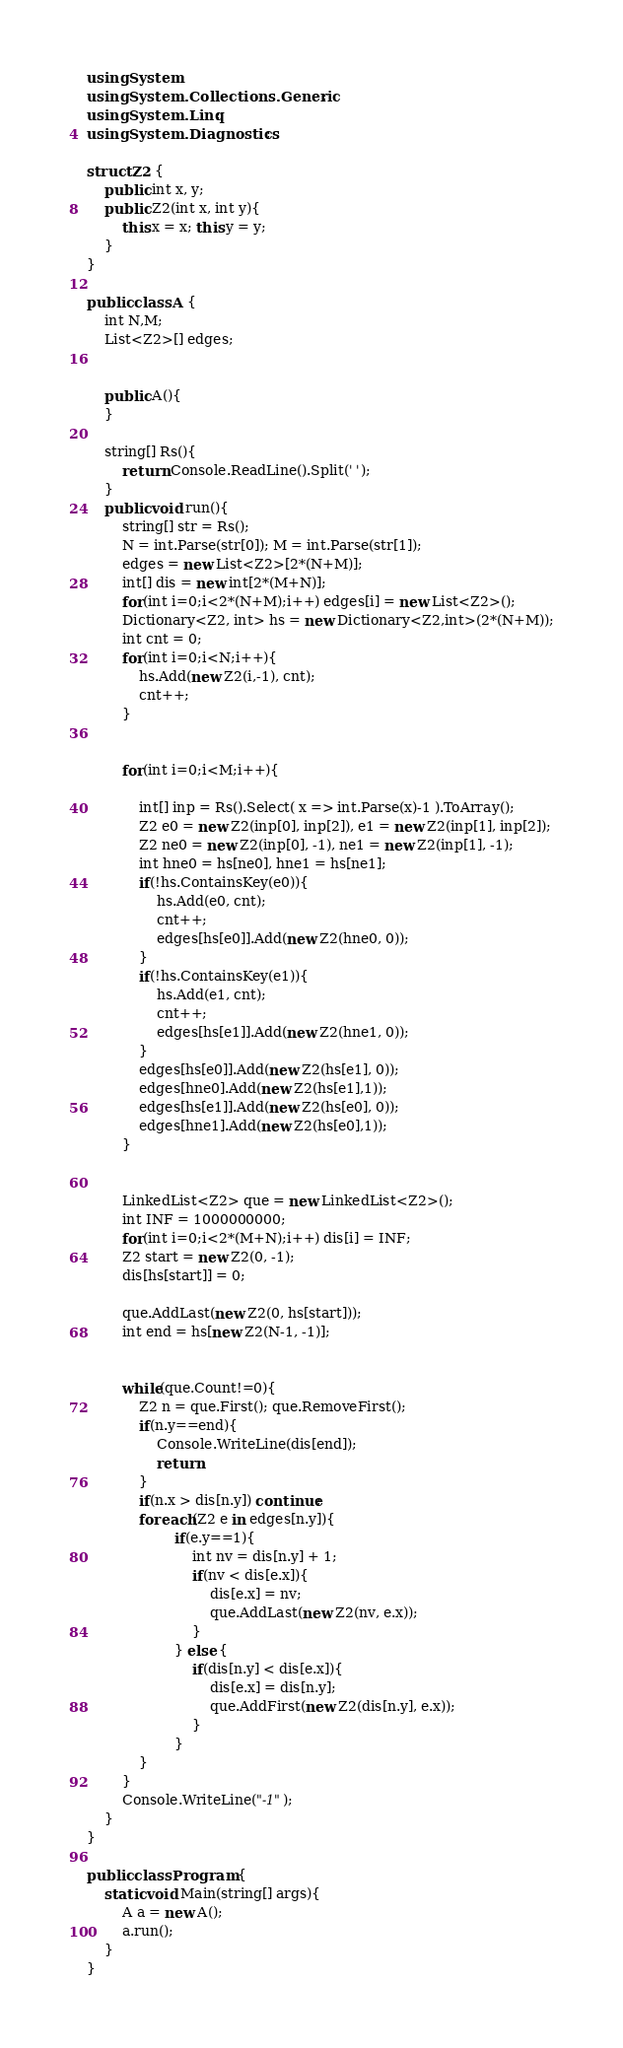Convert code to text. <code><loc_0><loc_0><loc_500><loc_500><_C#_>using System;
using System.Collections.Generic;
using System.Linq;
using System.Diagnostics;
 
struct Z2 {
	public int x, y;
	public Z2(int x, int y){
		this.x = x; this.y = y;
	}
}
 
public class A {
	int N,M;
	List<Z2>[] edges;
    
	
	public A(){
	}
	
	string[] Rs(){
		return Console.ReadLine().Split(' ');
	}
	public void run(){
        string[] str = Rs();
		N = int.Parse(str[0]); M = int.Parse(str[1]);
        edges = new List<Z2>[2*(N+M)];
        int[] dis = new int[2*(M+N)];
        for(int i=0;i<2*(N+M);i++) edges[i] = new List<Z2>();
        Dictionary<Z2, int> hs = new Dictionary<Z2,int>(2*(N+M));
		int cnt = 0;
        for(int i=0;i<N;i++){
            hs.Add(new Z2(i,-1), cnt);
            cnt++;
        }
        
        
        for(int i=0;i<M;i++){
            
			int[] inp = Rs().Select( x => int.Parse(x)-1 ).ToArray();
            Z2 e0 = new Z2(inp[0], inp[2]), e1 = new Z2(inp[1], inp[2]);
            Z2 ne0 = new Z2(inp[0], -1), ne1 = new Z2(inp[1], -1);
            int hne0 = hs[ne0], hne1 = hs[ne1];
            if(!hs.ContainsKey(e0)){
                hs.Add(e0, cnt);
                cnt++;
                edges[hs[e0]].Add(new Z2(hne0, 0));
            }
            if(!hs.ContainsKey(e1)){
                hs.Add(e1, cnt);
                cnt++;
                edges[hs[e1]].Add(new Z2(hne1, 0));
            }
            edges[hs[e0]].Add(new Z2(hs[e1], 0));
            edges[hne0].Add(new Z2(hs[e1],1));
            edges[hs[e1]].Add(new Z2(hs[e0], 0));
            edges[hne1].Add(new Z2(hs[e0],1));
        }
        
        
		LinkedList<Z2> que = new LinkedList<Z2>();
        int INF = 1000000000;
        for(int i=0;i<2*(M+N);i++) dis[i] = INF;
        Z2 start = new Z2(0, -1);
        dis[hs[start]] = 0;
		
		que.AddLast(new Z2(0, hs[start])); 
        int end = hs[new Z2(N-1, -1)];
        
        
		while(que.Count!=0){
			Z2 n = que.First(); que.RemoveFirst();
			if(n.y==end){ 
				Console.WriteLine(dis[end]);
				return;
			}
			if(n.x > dis[n.y]) continue;
            foreach(Z2 e in edges[n.y]){
					if(e.y==1){
						int nv = dis[n.y] + 1;
	                    if(nv < dis[e.x]){
							dis[e.x] = nv;
							que.AddLast(new Z2(nv, e.x));
						}
					} else {
						if(dis[n.y] < dis[e.x]){
							dis[e.x] = dis[n.y];
							que.AddFirst(new Z2(dis[n.y], e.x));
						}
					}
            }
        }
		Console.WriteLine("-1");
	}
}
 
public class Program {
	static void Main(string[] args){
		A a = new A();
		a.run();
	}
}</code> 